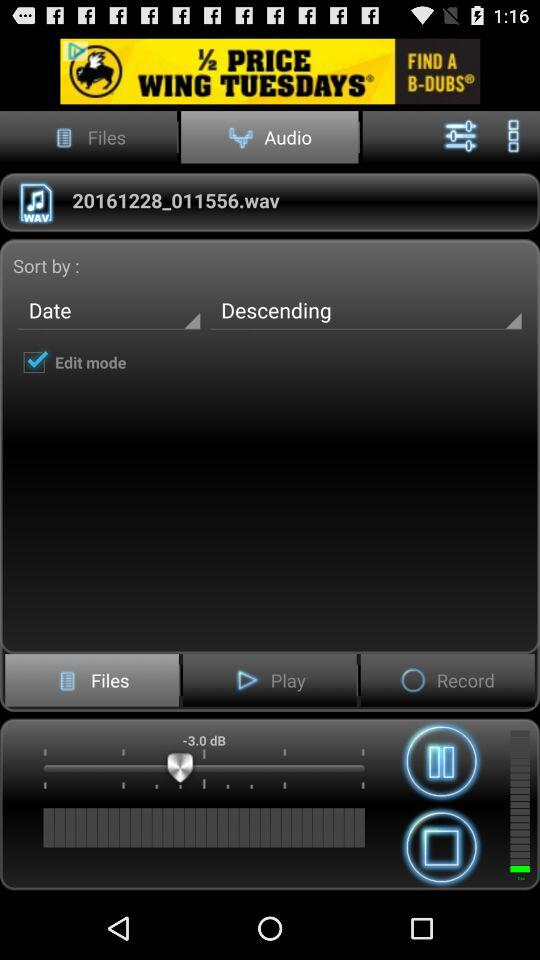What is the name of the file that is selected?
Answer the question using a single word or phrase. 20161228_011556.wav 